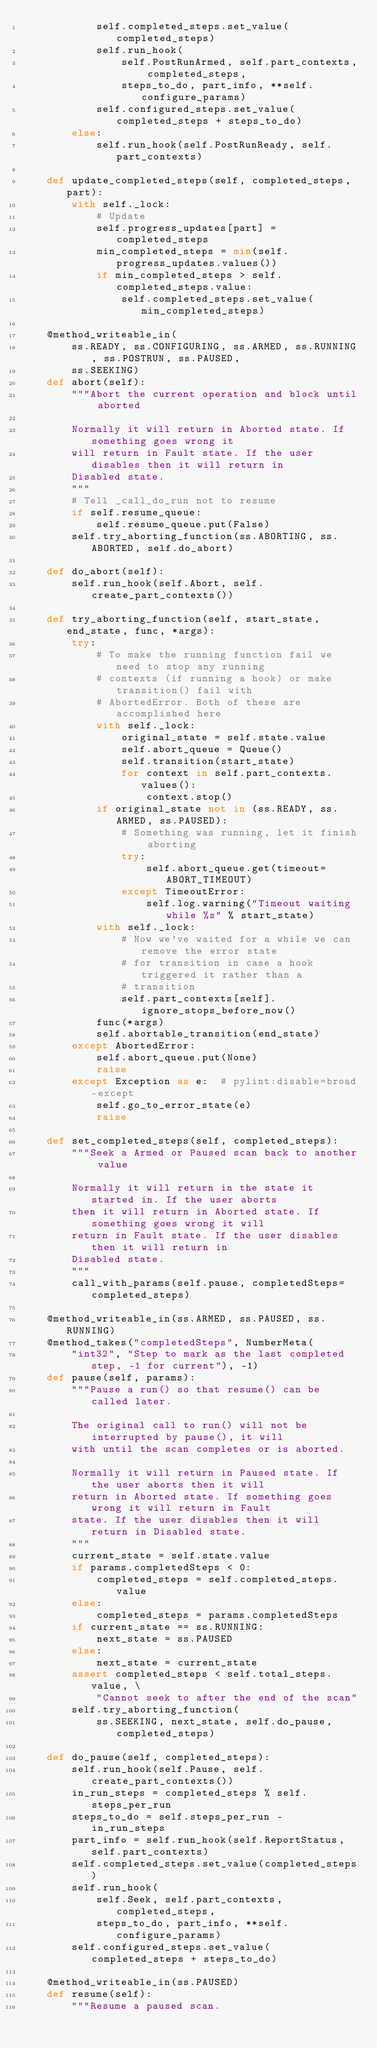Convert code to text. <code><loc_0><loc_0><loc_500><loc_500><_Python_>            self.completed_steps.set_value(completed_steps)
            self.run_hook(
                self.PostRunArmed, self.part_contexts, completed_steps,
                steps_to_do, part_info, **self.configure_params)
            self.configured_steps.set_value(completed_steps + steps_to_do)
        else:
            self.run_hook(self.PostRunReady, self.part_contexts)

    def update_completed_steps(self, completed_steps, part):
        with self._lock:
            # Update
            self.progress_updates[part] = completed_steps
            min_completed_steps = min(self.progress_updates.values())
            if min_completed_steps > self.completed_steps.value:
                self.completed_steps.set_value(min_completed_steps)

    @method_writeable_in(
        ss.READY, ss.CONFIGURING, ss.ARMED, ss.RUNNING, ss.POSTRUN, ss.PAUSED,
        ss.SEEKING)
    def abort(self):
        """Abort the current operation and block until aborted

        Normally it will return in Aborted state. If something goes wrong it
        will return in Fault state. If the user disables then it will return in
        Disabled state.
        """
        # Tell _call_do_run not to resume
        if self.resume_queue:
            self.resume_queue.put(False)
        self.try_aborting_function(ss.ABORTING, ss.ABORTED, self.do_abort)

    def do_abort(self):
        self.run_hook(self.Abort, self.create_part_contexts())

    def try_aborting_function(self, start_state, end_state, func, *args):
        try:
            # To make the running function fail we need to stop any running
            # contexts (if running a hook) or make transition() fail with
            # AbortedError. Both of these are accomplished here
            with self._lock:
                original_state = self.state.value
                self.abort_queue = Queue()
                self.transition(start_state)
                for context in self.part_contexts.values():
                    context.stop()
            if original_state not in (ss.READY, ss.ARMED, ss.PAUSED):
                # Something was running, let it finish aborting
                try:
                    self.abort_queue.get(timeout=ABORT_TIMEOUT)
                except TimeoutError:
                    self.log.warning("Timeout waiting while %s" % start_state)
            with self._lock:
                # Now we've waited for a while we can remove the error state
                # for transition in case a hook triggered it rather than a
                # transition
                self.part_contexts[self].ignore_stops_before_now()
            func(*args)
            self.abortable_transition(end_state)
        except AbortedError:
            self.abort_queue.put(None)
            raise
        except Exception as e:  # pylint:disable=broad-except
            self.go_to_error_state(e)
            raise

    def set_completed_steps(self, completed_steps):
        """Seek a Armed or Paused scan back to another value

        Normally it will return in the state it started in. If the user aborts
        then it will return in Aborted state. If something goes wrong it will
        return in Fault state. If the user disables then it will return in
        Disabled state.
        """
        call_with_params(self.pause, completedSteps=completed_steps)

    @method_writeable_in(ss.ARMED, ss.PAUSED, ss.RUNNING)
    @method_takes("completedSteps", NumberMeta(
        "int32", "Step to mark as the last completed step, -1 for current"), -1)
    def pause(self, params):
        """Pause a run() so that resume() can be called later.

        The original call to run() will not be interrupted by pause(), it will
        with until the scan completes or is aborted.

        Normally it will return in Paused state. If the user aborts then it will
        return in Aborted state. If something goes wrong it will return in Fault
        state. If the user disables then it will return in Disabled state.
        """
        current_state = self.state.value
        if params.completedSteps < 0:
            completed_steps = self.completed_steps.value
        else:
            completed_steps = params.completedSteps
        if current_state == ss.RUNNING:
            next_state = ss.PAUSED
        else:
            next_state = current_state
        assert completed_steps < self.total_steps.value, \
            "Cannot seek to after the end of the scan"
        self.try_aborting_function(
            ss.SEEKING, next_state, self.do_pause, completed_steps)

    def do_pause(self, completed_steps):
        self.run_hook(self.Pause, self.create_part_contexts())
        in_run_steps = completed_steps % self.steps_per_run
        steps_to_do = self.steps_per_run - in_run_steps
        part_info = self.run_hook(self.ReportStatus, self.part_contexts)
        self.completed_steps.set_value(completed_steps)
        self.run_hook(
            self.Seek, self.part_contexts, completed_steps,
            steps_to_do, part_info, **self.configure_params)
        self.configured_steps.set_value(completed_steps + steps_to_do)

    @method_writeable_in(ss.PAUSED)
    def resume(self):
        """Resume a paused scan.
</code> 